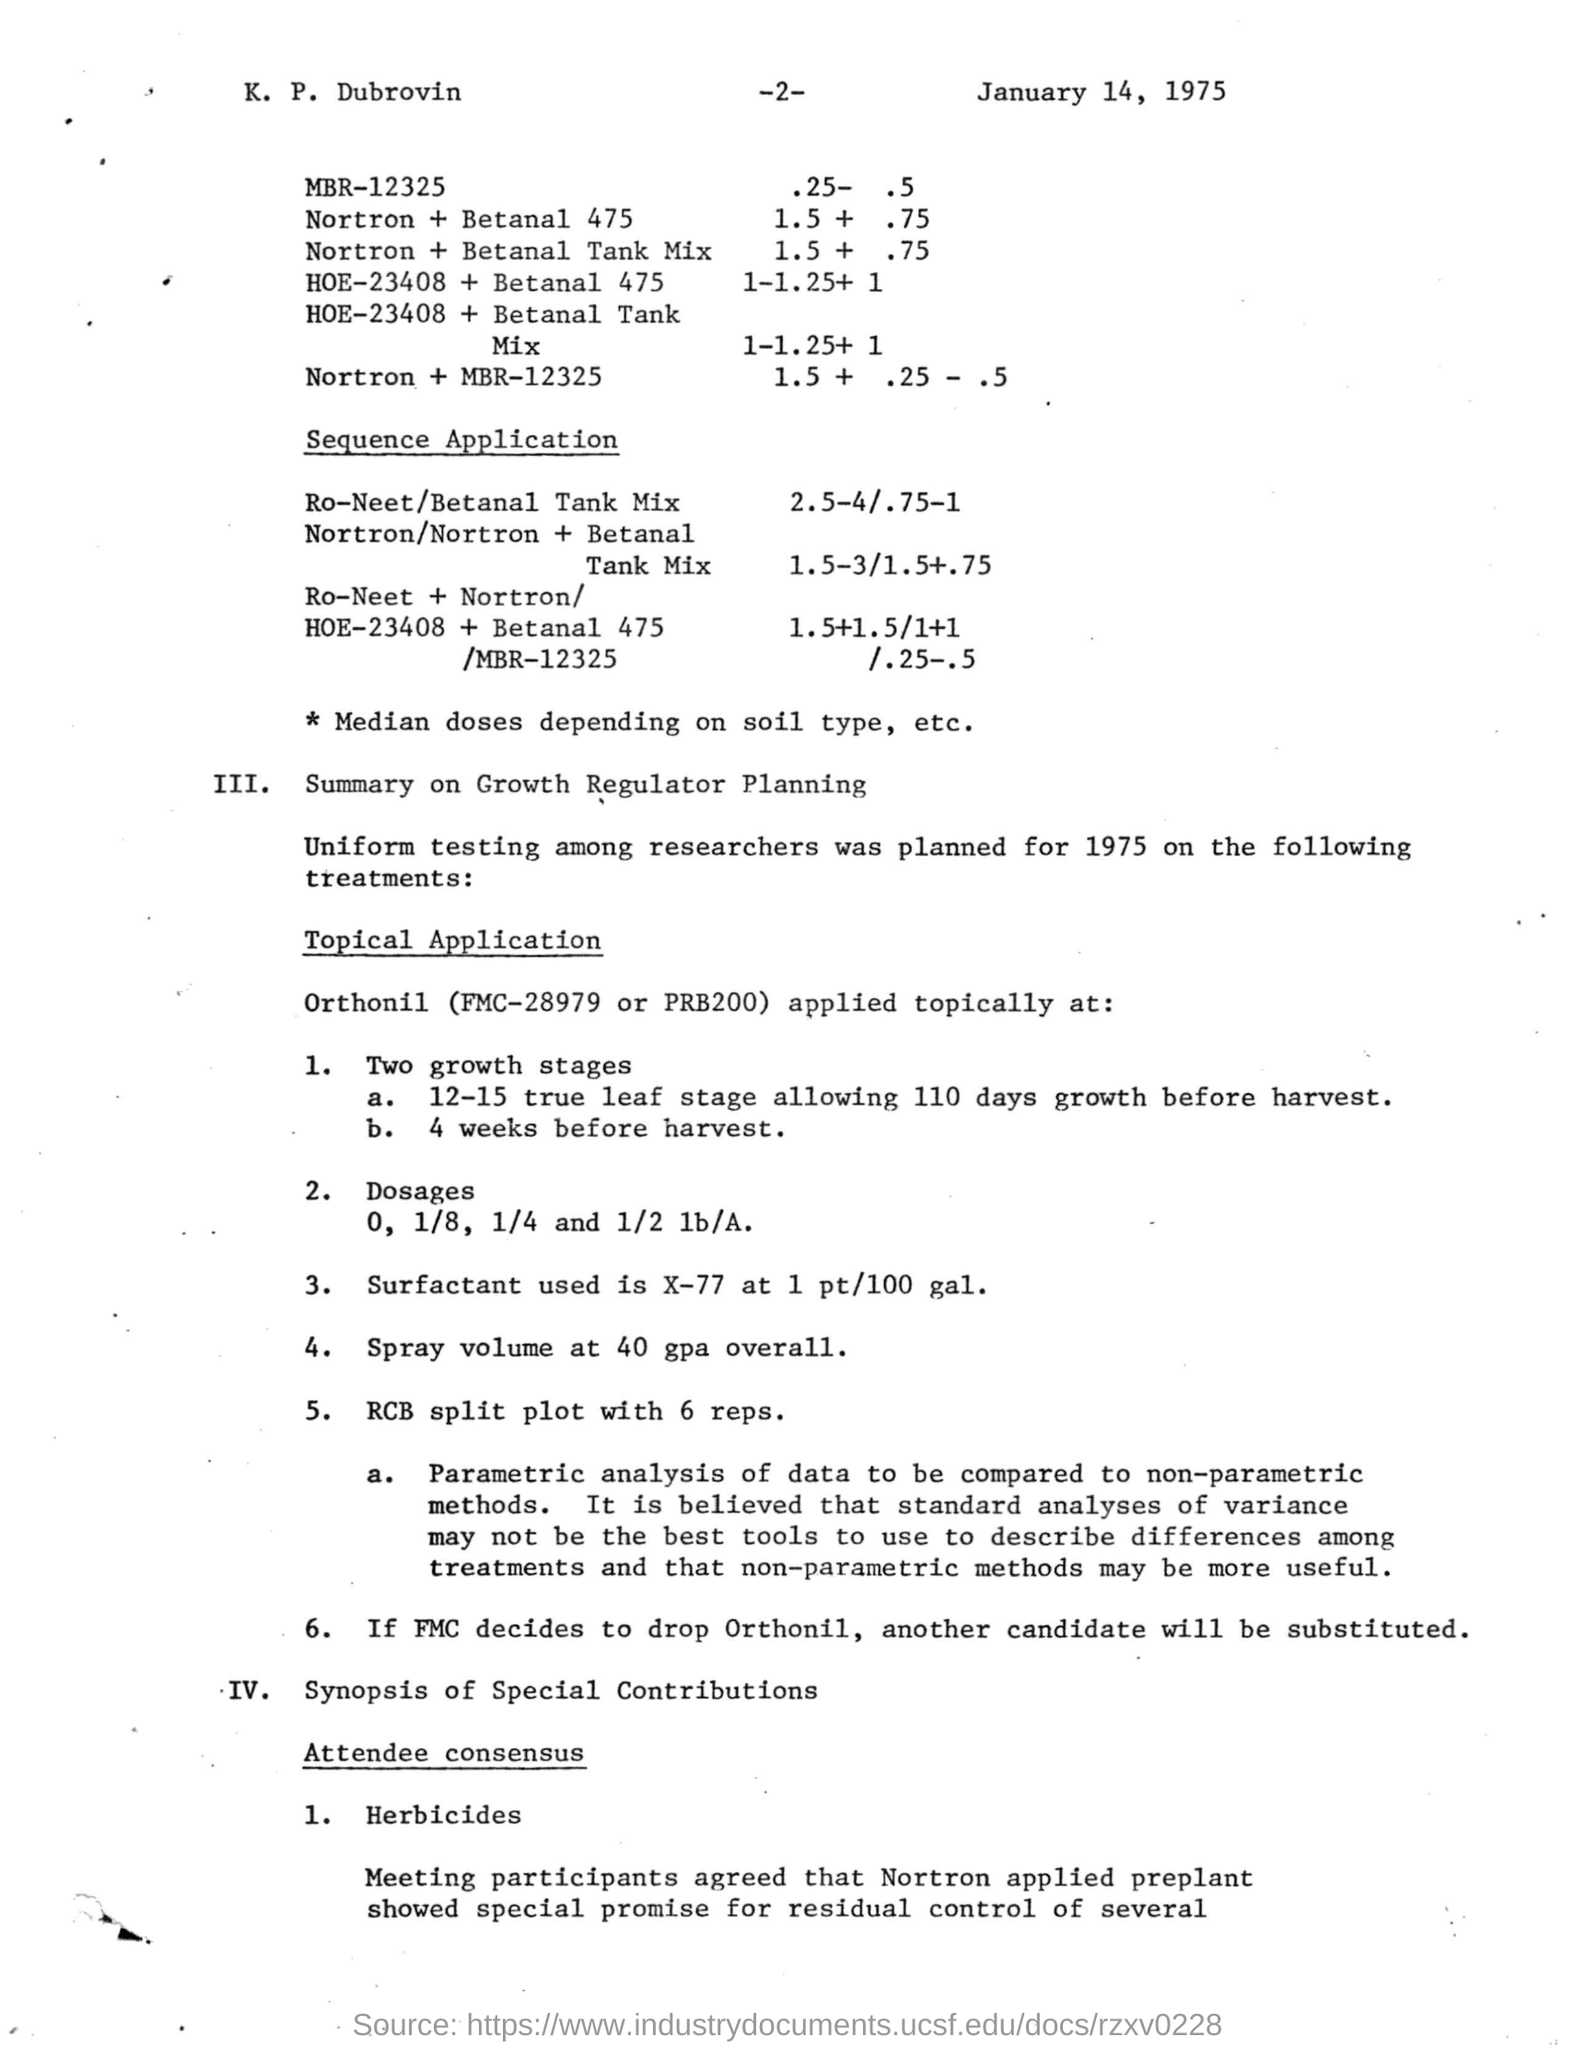Indicate a few pertinent items in this graphic. The date mentioned in the given page is January 14, 1975. 